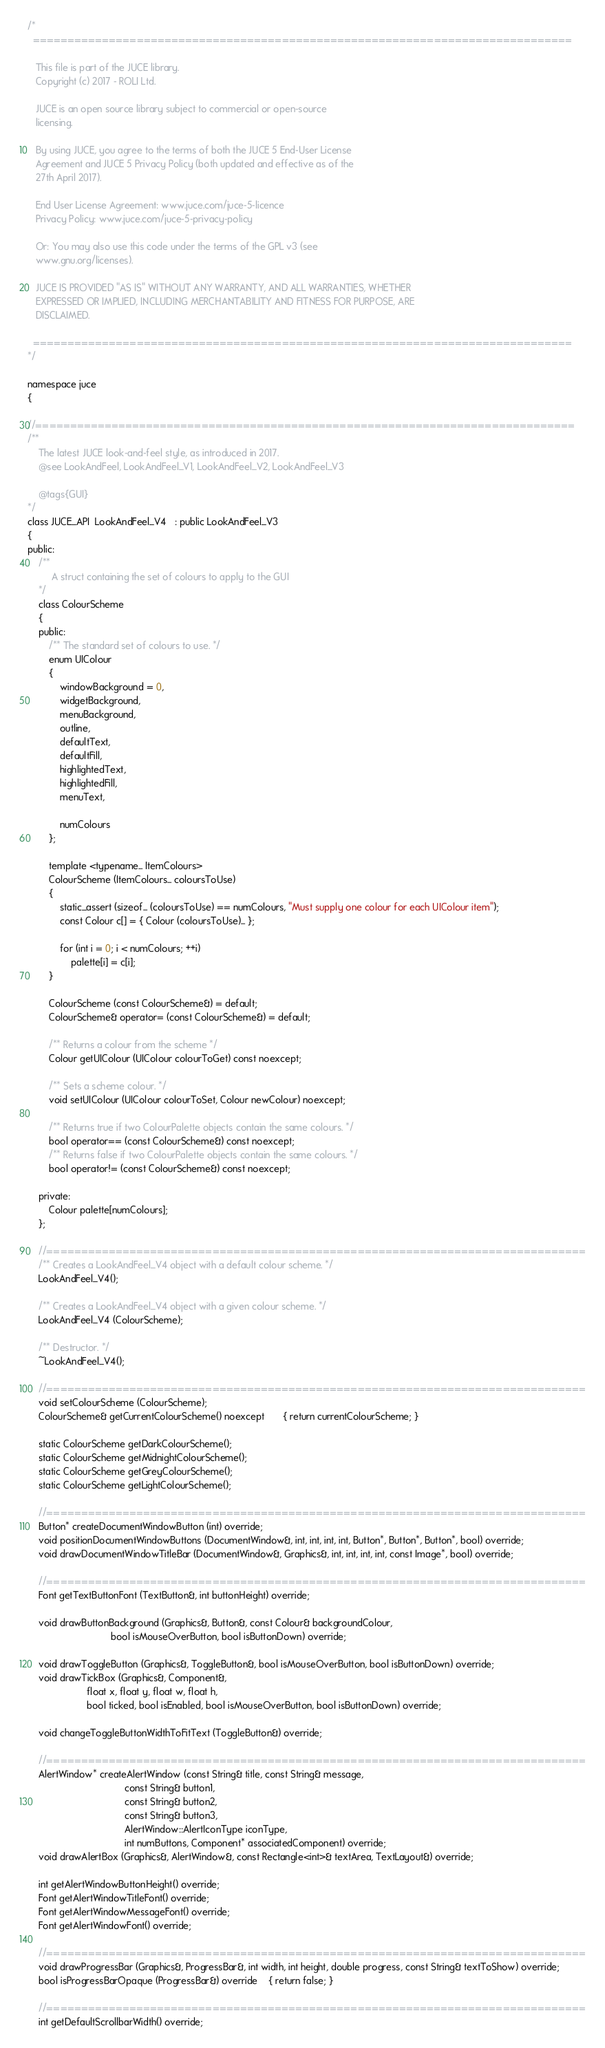<code> <loc_0><loc_0><loc_500><loc_500><_C_>/*
  ==============================================================================

   This file is part of the JUCE library.
   Copyright (c) 2017 - ROLI Ltd.

   JUCE is an open source library subject to commercial or open-source
   licensing.

   By using JUCE, you agree to the terms of both the JUCE 5 End-User License
   Agreement and JUCE 5 Privacy Policy (both updated and effective as of the
   27th April 2017).

   End User License Agreement: www.juce.com/juce-5-licence
   Privacy Policy: www.juce.com/juce-5-privacy-policy

   Or: You may also use this code under the terms of the GPL v3 (see
   www.gnu.org/licenses).

   JUCE IS PROVIDED "AS IS" WITHOUT ANY WARRANTY, AND ALL WARRANTIES, WHETHER
   EXPRESSED OR IMPLIED, INCLUDING MERCHANTABILITY AND FITNESS FOR PURPOSE, ARE
   DISCLAIMED.

  ==============================================================================
*/

namespace juce
{

//==============================================================================
/**
    The latest JUCE look-and-feel style, as introduced in 2017.
    @see LookAndFeel, LookAndFeel_V1, LookAndFeel_V2, LookAndFeel_V3

    @tags{GUI}
*/
class JUCE_API  LookAndFeel_V4   : public LookAndFeel_V3
{
public:
    /**
         A struct containing the set of colours to apply to the GUI
    */
    class ColourScheme
    {
    public:
        /** The standard set of colours to use. */
        enum UIColour
        {
            windowBackground = 0,
            widgetBackground,
            menuBackground,
            outline,
            defaultText,
            defaultFill,
            highlightedText,
            highlightedFill,
            menuText,

            numColours
        };

        template <typename... ItemColours>
        ColourScheme (ItemColours... coloursToUse)
        {
            static_assert (sizeof... (coloursToUse) == numColours, "Must supply one colour for each UIColour item");
            const Colour c[] = { Colour (coloursToUse)... };

            for (int i = 0; i < numColours; ++i)
                palette[i] = c[i];
        }

        ColourScheme (const ColourScheme&) = default;
        ColourScheme& operator= (const ColourScheme&) = default;

        /** Returns a colour from the scheme */
        Colour getUIColour (UIColour colourToGet) const noexcept;

        /** Sets a scheme colour. */
        void setUIColour (UIColour colourToSet, Colour newColour) noexcept;

        /** Returns true if two ColourPalette objects contain the same colours. */
        bool operator== (const ColourScheme&) const noexcept;
        /** Returns false if two ColourPalette objects contain the same colours. */
        bool operator!= (const ColourScheme&) const noexcept;

    private:
        Colour palette[numColours];
    };

    //==============================================================================
    /** Creates a LookAndFeel_V4 object with a default colour scheme. */
    LookAndFeel_V4();

    /** Creates a LookAndFeel_V4 object with a given colour scheme. */
    LookAndFeel_V4 (ColourScheme);

    /** Destructor. */
    ~LookAndFeel_V4();

    //==============================================================================
    void setColourScheme (ColourScheme);
    ColourScheme& getCurrentColourScheme() noexcept       { return currentColourScheme; }

    static ColourScheme getDarkColourScheme();
    static ColourScheme getMidnightColourScheme();
    static ColourScheme getGreyColourScheme();
    static ColourScheme getLightColourScheme();

    //==============================================================================
    Button* createDocumentWindowButton (int) override;
    void positionDocumentWindowButtons (DocumentWindow&, int, int, int, int, Button*, Button*, Button*, bool) override;
    void drawDocumentWindowTitleBar (DocumentWindow&, Graphics&, int, int, int, int, const Image*, bool) override;

    //==============================================================================
    Font getTextButtonFont (TextButton&, int buttonHeight) override;

    void drawButtonBackground (Graphics&, Button&, const Colour& backgroundColour,
                               bool isMouseOverButton, bool isButtonDown) override;

    void drawToggleButton (Graphics&, ToggleButton&, bool isMouseOverButton, bool isButtonDown) override;
    void drawTickBox (Graphics&, Component&,
                      float x, float y, float w, float h,
                      bool ticked, bool isEnabled, bool isMouseOverButton, bool isButtonDown) override;

    void changeToggleButtonWidthToFitText (ToggleButton&) override;

    //==============================================================================
    AlertWindow* createAlertWindow (const String& title, const String& message,
                                    const String& button1,
                                    const String& button2,
                                    const String& button3,
                                    AlertWindow::AlertIconType iconType,
                                    int numButtons, Component* associatedComponent) override;
    void drawAlertBox (Graphics&, AlertWindow&, const Rectangle<int>& textArea, TextLayout&) override;

    int getAlertWindowButtonHeight() override;
    Font getAlertWindowTitleFont() override;
    Font getAlertWindowMessageFont() override;
    Font getAlertWindowFont() override;

    //==============================================================================
    void drawProgressBar (Graphics&, ProgressBar&, int width, int height, double progress, const String& textToShow) override;
    bool isProgressBarOpaque (ProgressBar&) override    { return false; }

    //==============================================================================
    int getDefaultScrollbarWidth() override;</code> 